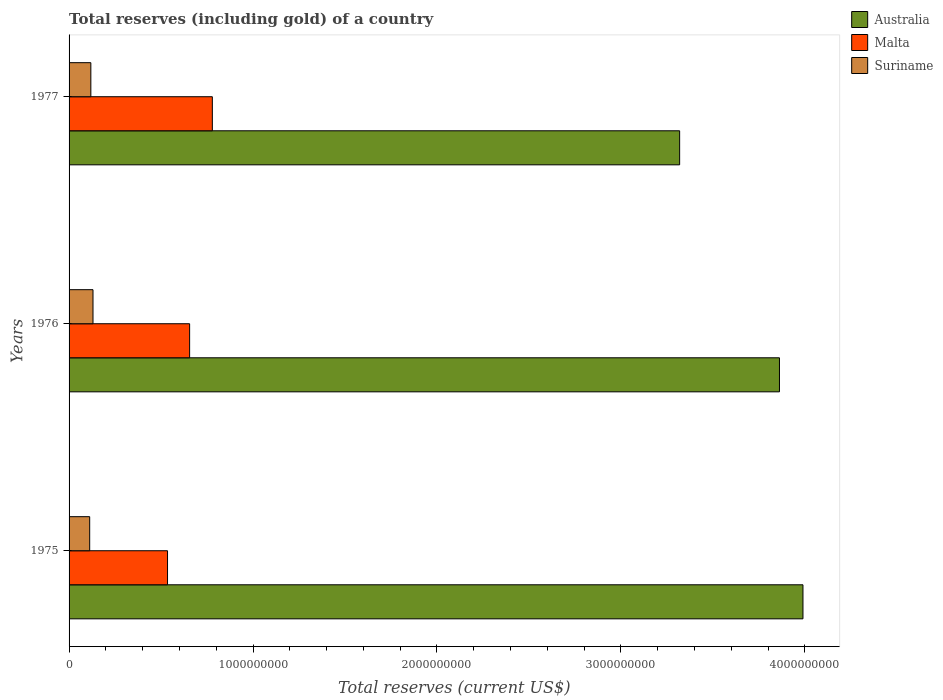How many different coloured bars are there?
Give a very brief answer. 3. How many groups of bars are there?
Your answer should be compact. 3. Are the number of bars on each tick of the Y-axis equal?
Your answer should be very brief. Yes. How many bars are there on the 2nd tick from the top?
Offer a very short reply. 3. How many bars are there on the 2nd tick from the bottom?
Offer a very short reply. 3. What is the label of the 2nd group of bars from the top?
Provide a succinct answer. 1976. What is the total reserves (including gold) in Suriname in 1976?
Ensure brevity in your answer.  1.30e+08. Across all years, what is the maximum total reserves (including gold) in Suriname?
Your response must be concise. 1.30e+08. Across all years, what is the minimum total reserves (including gold) in Malta?
Give a very brief answer. 5.35e+08. In which year was the total reserves (including gold) in Malta minimum?
Offer a terse response. 1975. What is the total total reserves (including gold) in Suriname in the graph?
Give a very brief answer. 3.61e+08. What is the difference between the total reserves (including gold) in Malta in 1976 and that in 1977?
Ensure brevity in your answer.  -1.24e+08. What is the difference between the total reserves (including gold) in Malta in 1975 and the total reserves (including gold) in Suriname in 1976?
Ensure brevity in your answer.  4.05e+08. What is the average total reserves (including gold) in Suriname per year?
Offer a very short reply. 1.20e+08. In the year 1976, what is the difference between the total reserves (including gold) in Australia and total reserves (including gold) in Malta?
Give a very brief answer. 3.21e+09. In how many years, is the total reserves (including gold) in Australia greater than 2400000000 US$?
Make the answer very short. 3. What is the ratio of the total reserves (including gold) in Australia in 1975 to that in 1976?
Give a very brief answer. 1.03. Is the total reserves (including gold) in Malta in 1975 less than that in 1977?
Keep it short and to the point. Yes. Is the difference between the total reserves (including gold) in Australia in 1975 and 1977 greater than the difference between the total reserves (including gold) in Malta in 1975 and 1977?
Keep it short and to the point. Yes. What is the difference between the highest and the second highest total reserves (including gold) in Suriname?
Ensure brevity in your answer.  1.17e+07. What is the difference between the highest and the lowest total reserves (including gold) in Malta?
Your answer should be very brief. 2.44e+08. Is the sum of the total reserves (including gold) in Suriname in 1976 and 1977 greater than the maximum total reserves (including gold) in Australia across all years?
Offer a terse response. No. What does the 2nd bar from the top in 1975 represents?
Keep it short and to the point. Malta. What does the 3rd bar from the bottom in 1976 represents?
Make the answer very short. Suriname. Is it the case that in every year, the sum of the total reserves (including gold) in Suriname and total reserves (including gold) in Australia is greater than the total reserves (including gold) in Malta?
Offer a terse response. Yes. How many bars are there?
Keep it short and to the point. 9. Are all the bars in the graph horizontal?
Ensure brevity in your answer.  Yes. What is the difference between two consecutive major ticks on the X-axis?
Provide a succinct answer. 1.00e+09. Are the values on the major ticks of X-axis written in scientific E-notation?
Give a very brief answer. No. Does the graph contain any zero values?
Your answer should be very brief. No. Does the graph contain grids?
Your answer should be compact. No. How many legend labels are there?
Your response must be concise. 3. What is the title of the graph?
Make the answer very short. Total reserves (including gold) of a country. Does "Europe(all income levels)" appear as one of the legend labels in the graph?
Give a very brief answer. No. What is the label or title of the X-axis?
Your answer should be compact. Total reserves (current US$). What is the Total reserves (current US$) of Australia in 1975?
Offer a terse response. 3.99e+09. What is the Total reserves (current US$) of Malta in 1975?
Your answer should be very brief. 5.35e+08. What is the Total reserves (current US$) of Suriname in 1975?
Ensure brevity in your answer.  1.12e+08. What is the Total reserves (current US$) of Australia in 1976?
Your answer should be very brief. 3.86e+09. What is the Total reserves (current US$) in Malta in 1976?
Provide a succinct answer. 6.55e+08. What is the Total reserves (current US$) in Suriname in 1976?
Keep it short and to the point. 1.30e+08. What is the Total reserves (current US$) in Australia in 1977?
Keep it short and to the point. 3.32e+09. What is the Total reserves (current US$) of Malta in 1977?
Offer a very short reply. 7.79e+08. What is the Total reserves (current US$) in Suriname in 1977?
Provide a short and direct response. 1.18e+08. Across all years, what is the maximum Total reserves (current US$) of Australia?
Your response must be concise. 3.99e+09. Across all years, what is the maximum Total reserves (current US$) in Malta?
Keep it short and to the point. 7.79e+08. Across all years, what is the maximum Total reserves (current US$) in Suriname?
Give a very brief answer. 1.30e+08. Across all years, what is the minimum Total reserves (current US$) of Australia?
Offer a very short reply. 3.32e+09. Across all years, what is the minimum Total reserves (current US$) of Malta?
Your answer should be very brief. 5.35e+08. Across all years, what is the minimum Total reserves (current US$) in Suriname?
Keep it short and to the point. 1.12e+08. What is the total Total reserves (current US$) of Australia in the graph?
Ensure brevity in your answer.  1.12e+1. What is the total Total reserves (current US$) in Malta in the graph?
Your answer should be compact. 1.97e+09. What is the total Total reserves (current US$) in Suriname in the graph?
Your answer should be very brief. 3.61e+08. What is the difference between the Total reserves (current US$) in Australia in 1975 and that in 1976?
Make the answer very short. 1.28e+08. What is the difference between the Total reserves (current US$) in Malta in 1975 and that in 1976?
Provide a short and direct response. -1.20e+08. What is the difference between the Total reserves (current US$) in Suriname in 1975 and that in 1976?
Your response must be concise. -1.80e+07. What is the difference between the Total reserves (current US$) of Australia in 1975 and that in 1977?
Your answer should be very brief. 6.71e+08. What is the difference between the Total reserves (current US$) in Malta in 1975 and that in 1977?
Your response must be concise. -2.44e+08. What is the difference between the Total reserves (current US$) of Suriname in 1975 and that in 1977?
Provide a succinct answer. -6.26e+06. What is the difference between the Total reserves (current US$) of Australia in 1976 and that in 1977?
Offer a terse response. 5.43e+08. What is the difference between the Total reserves (current US$) in Malta in 1976 and that in 1977?
Ensure brevity in your answer.  -1.24e+08. What is the difference between the Total reserves (current US$) in Suriname in 1976 and that in 1977?
Keep it short and to the point. 1.17e+07. What is the difference between the Total reserves (current US$) of Australia in 1975 and the Total reserves (current US$) of Malta in 1976?
Keep it short and to the point. 3.33e+09. What is the difference between the Total reserves (current US$) of Australia in 1975 and the Total reserves (current US$) of Suriname in 1976?
Keep it short and to the point. 3.86e+09. What is the difference between the Total reserves (current US$) of Malta in 1975 and the Total reserves (current US$) of Suriname in 1976?
Offer a very short reply. 4.05e+08. What is the difference between the Total reserves (current US$) of Australia in 1975 and the Total reserves (current US$) of Malta in 1977?
Offer a terse response. 3.21e+09. What is the difference between the Total reserves (current US$) of Australia in 1975 and the Total reserves (current US$) of Suriname in 1977?
Your answer should be very brief. 3.87e+09. What is the difference between the Total reserves (current US$) in Malta in 1975 and the Total reserves (current US$) in Suriname in 1977?
Your answer should be very brief. 4.17e+08. What is the difference between the Total reserves (current US$) in Australia in 1976 and the Total reserves (current US$) in Malta in 1977?
Provide a succinct answer. 3.08e+09. What is the difference between the Total reserves (current US$) in Australia in 1976 and the Total reserves (current US$) in Suriname in 1977?
Give a very brief answer. 3.74e+09. What is the difference between the Total reserves (current US$) of Malta in 1976 and the Total reserves (current US$) of Suriname in 1977?
Give a very brief answer. 5.37e+08. What is the average Total reserves (current US$) in Australia per year?
Give a very brief answer. 3.72e+09. What is the average Total reserves (current US$) in Malta per year?
Offer a very short reply. 6.57e+08. What is the average Total reserves (current US$) of Suriname per year?
Make the answer very short. 1.20e+08. In the year 1975, what is the difference between the Total reserves (current US$) of Australia and Total reserves (current US$) of Malta?
Provide a succinct answer. 3.45e+09. In the year 1975, what is the difference between the Total reserves (current US$) in Australia and Total reserves (current US$) in Suriname?
Your response must be concise. 3.88e+09. In the year 1975, what is the difference between the Total reserves (current US$) of Malta and Total reserves (current US$) of Suriname?
Keep it short and to the point. 4.23e+08. In the year 1976, what is the difference between the Total reserves (current US$) of Australia and Total reserves (current US$) of Malta?
Your answer should be compact. 3.21e+09. In the year 1976, what is the difference between the Total reserves (current US$) of Australia and Total reserves (current US$) of Suriname?
Offer a terse response. 3.73e+09. In the year 1976, what is the difference between the Total reserves (current US$) of Malta and Total reserves (current US$) of Suriname?
Your answer should be very brief. 5.25e+08. In the year 1977, what is the difference between the Total reserves (current US$) of Australia and Total reserves (current US$) of Malta?
Provide a short and direct response. 2.54e+09. In the year 1977, what is the difference between the Total reserves (current US$) of Australia and Total reserves (current US$) of Suriname?
Make the answer very short. 3.20e+09. In the year 1977, what is the difference between the Total reserves (current US$) of Malta and Total reserves (current US$) of Suriname?
Your answer should be very brief. 6.61e+08. What is the ratio of the Total reserves (current US$) of Australia in 1975 to that in 1976?
Ensure brevity in your answer.  1.03. What is the ratio of the Total reserves (current US$) in Malta in 1975 to that in 1976?
Your response must be concise. 0.82. What is the ratio of the Total reserves (current US$) in Suriname in 1975 to that in 1976?
Make the answer very short. 0.86. What is the ratio of the Total reserves (current US$) in Australia in 1975 to that in 1977?
Provide a short and direct response. 1.2. What is the ratio of the Total reserves (current US$) in Malta in 1975 to that in 1977?
Make the answer very short. 0.69. What is the ratio of the Total reserves (current US$) of Suriname in 1975 to that in 1977?
Give a very brief answer. 0.95. What is the ratio of the Total reserves (current US$) in Australia in 1976 to that in 1977?
Keep it short and to the point. 1.16. What is the ratio of the Total reserves (current US$) of Malta in 1976 to that in 1977?
Ensure brevity in your answer.  0.84. What is the ratio of the Total reserves (current US$) in Suriname in 1976 to that in 1977?
Keep it short and to the point. 1.1. What is the difference between the highest and the second highest Total reserves (current US$) of Australia?
Your response must be concise. 1.28e+08. What is the difference between the highest and the second highest Total reserves (current US$) of Malta?
Give a very brief answer. 1.24e+08. What is the difference between the highest and the second highest Total reserves (current US$) of Suriname?
Your response must be concise. 1.17e+07. What is the difference between the highest and the lowest Total reserves (current US$) of Australia?
Provide a succinct answer. 6.71e+08. What is the difference between the highest and the lowest Total reserves (current US$) of Malta?
Offer a very short reply. 2.44e+08. What is the difference between the highest and the lowest Total reserves (current US$) of Suriname?
Ensure brevity in your answer.  1.80e+07. 